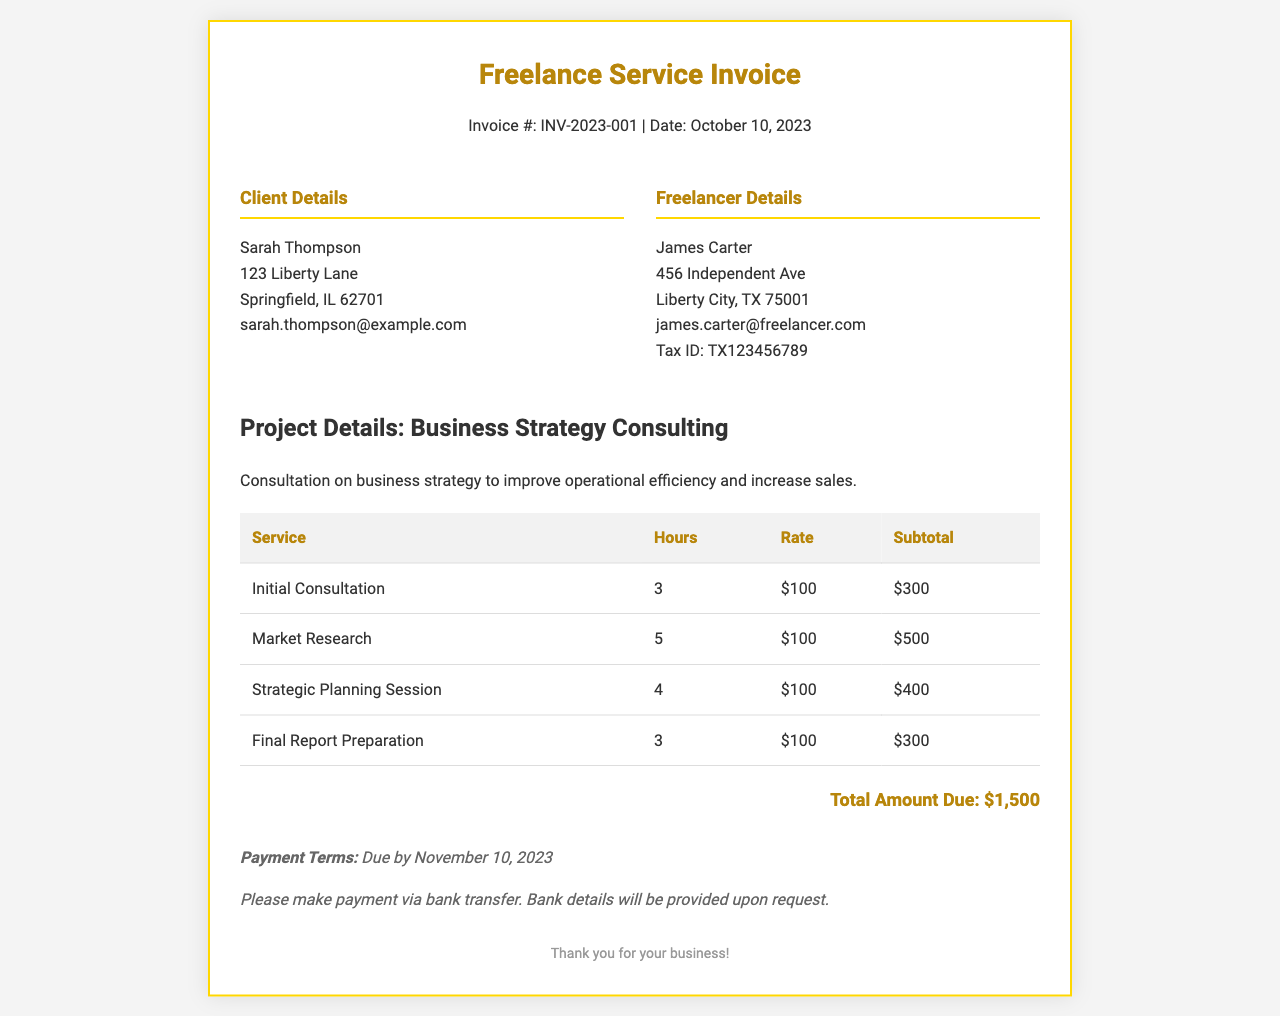What is the total amount due? The total amount due is listed in the invoice summary, which is $1,500.
Answer: $1,500 Who is the client? The client's name is included in the client details section of the invoice, which is Sarah Thompson.
Answer: Sarah Thompson What is the project title? The project title is provided under project details and is "Business Strategy Consulting."
Answer: Business Strategy Consulting How many hours were spent on Market Research? The hours spent on Market Research are detailed in the service table, which shows 5 hours.
Answer: 5 What is the hourly rate for services provided? The hourly rate for all services is consistently listed in the service table as $100.
Answer: $100 When is the payment due? The payment terms section states that the payment is due by November 10, 2023.
Answer: November 10, 2023 What is the subtotal for the Final Report Preparation? The subtotal for Final Report Preparation is outlined in the service table, which shows it as $300.
Answer: $300 What services were included in the invoice? The services provided are listed in the service table, including Initial Consultation, Market Research, Strategic Planning Session, and Final Report Preparation.
Answer: Initial Consultation, Market Research, Strategic Planning Session, Final Report Preparation What is the client's email address? The client's email address is part of the client details provided, which is sarah.thompson@example.com.
Answer: sarah.thompson@example.com 